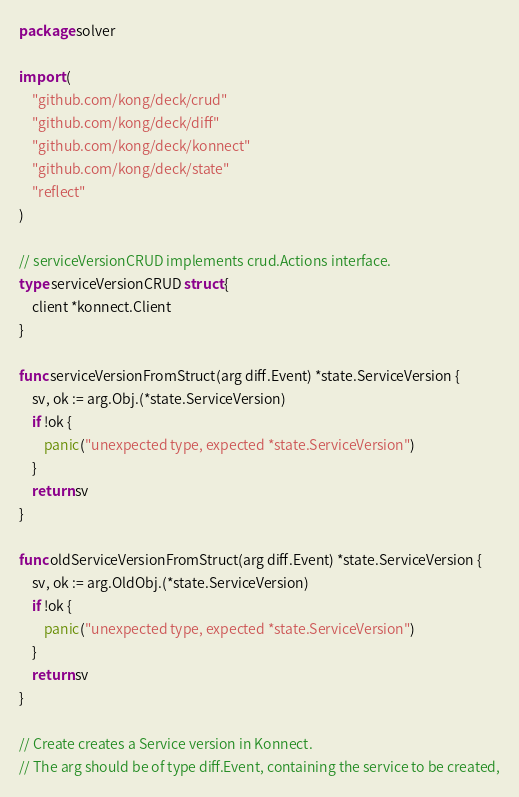Convert code to text. <code><loc_0><loc_0><loc_500><loc_500><_Go_>package solver

import (
	"github.com/kong/deck/crud"
	"github.com/kong/deck/diff"
	"github.com/kong/deck/konnect"
	"github.com/kong/deck/state"
	"reflect"
)

// serviceVersionCRUD implements crud.Actions interface.
type serviceVersionCRUD struct {
	client *konnect.Client
}

func serviceVersionFromStruct(arg diff.Event) *state.ServiceVersion {
	sv, ok := arg.Obj.(*state.ServiceVersion)
	if !ok {
		panic("unexpected type, expected *state.ServiceVersion")
	}
	return sv
}

func oldServiceVersionFromStruct(arg diff.Event) *state.ServiceVersion {
	sv, ok := arg.OldObj.(*state.ServiceVersion)
	if !ok {
		panic("unexpected type, expected *state.ServiceVersion")
	}
	return sv
}

// Create creates a Service version in Konnect.
// The arg should be of type diff.Event, containing the service to be created,</code> 